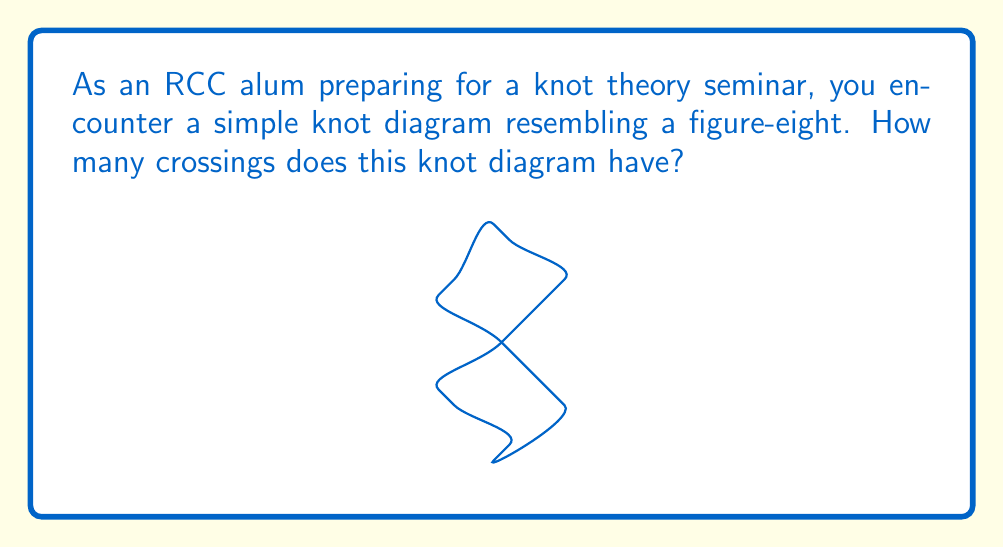Teach me how to tackle this problem. To identify the crossing number of a simple knot diagram, we need to count the number of crossings in the diagram. Let's approach this step-by-step:

1) First, let's define what a crossing is in knot theory. A crossing occurs when one strand of the knot passes over or under another strand in the two-dimensional projection of the knot.

2) In this figure-eight knot diagram, we can see that the knot intersects itself at four distinct points.

3) At each of these intersection points, one strand clearly passes over the other, creating a crossing.

4) Let's count these crossings:
   - There's a crossing at the top of the diagram
   - Another at the bottom of the diagram
   - One on the left side
   - And one on the right side

5) In total, we count 4 crossings in this simple knot diagram.

6) It's worth noting that the figure-eight knot (also known as the 4₁ knot in knot theory notation) is the simplest non-trivial knot with a crossing number greater than three. It cannot be simplified to have fewer crossings without changing its knot type.

Therefore, the crossing number of this simple knot diagram is 4.
Answer: 4 